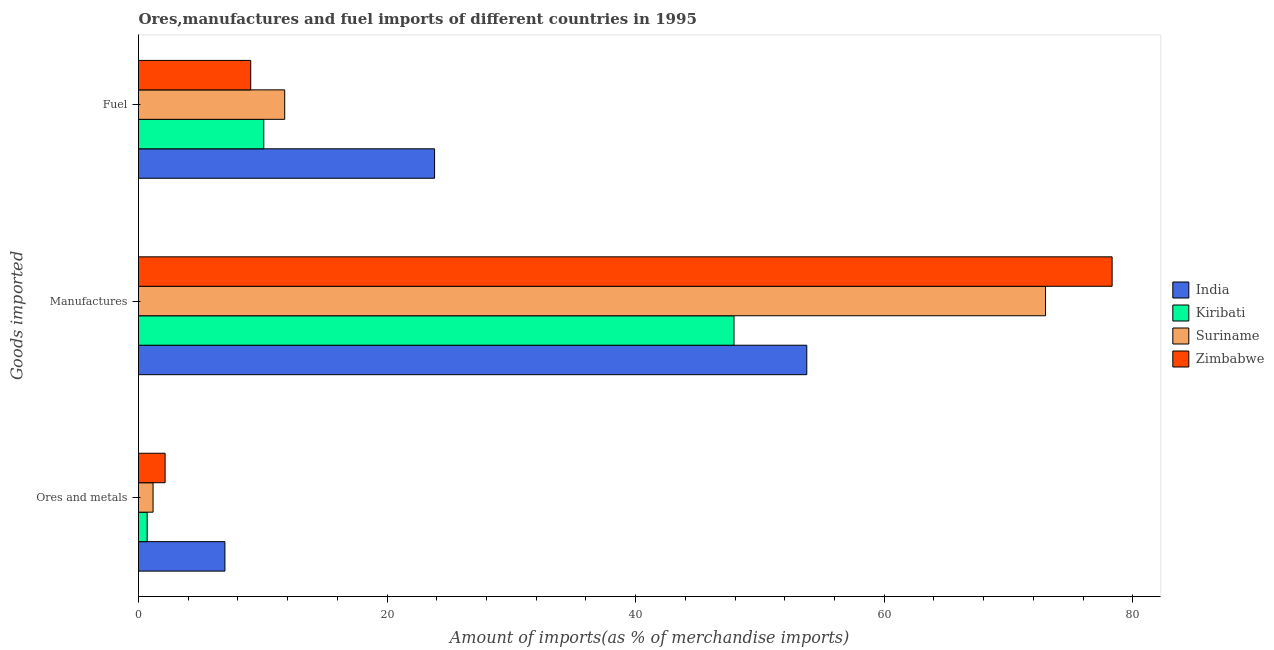How many different coloured bars are there?
Keep it short and to the point. 4. Are the number of bars on each tick of the Y-axis equal?
Offer a very short reply. Yes. How many bars are there on the 3rd tick from the top?
Your response must be concise. 4. How many bars are there on the 3rd tick from the bottom?
Your answer should be compact. 4. What is the label of the 3rd group of bars from the top?
Provide a short and direct response. Ores and metals. What is the percentage of manufactures imports in India?
Offer a terse response. 53.77. Across all countries, what is the maximum percentage of ores and metals imports?
Keep it short and to the point. 6.95. Across all countries, what is the minimum percentage of manufactures imports?
Keep it short and to the point. 47.92. In which country was the percentage of manufactures imports maximum?
Your answer should be very brief. Zimbabwe. In which country was the percentage of manufactures imports minimum?
Offer a very short reply. Kiribati. What is the total percentage of fuel imports in the graph?
Keep it short and to the point. 54.7. What is the difference between the percentage of fuel imports in Zimbabwe and that in Kiribati?
Offer a terse response. -1.05. What is the difference between the percentage of manufactures imports in Kiribati and the percentage of fuel imports in India?
Provide a succinct answer. 24.1. What is the average percentage of manufactures imports per country?
Give a very brief answer. 63.25. What is the difference between the percentage of manufactures imports and percentage of ores and metals imports in India?
Give a very brief answer. 46.82. What is the ratio of the percentage of manufactures imports in Suriname to that in Zimbabwe?
Offer a very short reply. 0.93. Is the percentage of manufactures imports in India less than that in Kiribati?
Provide a short and direct response. No. What is the difference between the highest and the second highest percentage of manufactures imports?
Provide a short and direct response. 5.36. What is the difference between the highest and the lowest percentage of fuel imports?
Your answer should be very brief. 14.79. In how many countries, is the percentage of fuel imports greater than the average percentage of fuel imports taken over all countries?
Your answer should be very brief. 1. Is the sum of the percentage of ores and metals imports in Kiribati and India greater than the maximum percentage of fuel imports across all countries?
Your answer should be very brief. No. What does the 1st bar from the top in Fuel represents?
Your answer should be very brief. Zimbabwe. What does the 2nd bar from the bottom in Fuel represents?
Offer a terse response. Kiribati. How many bars are there?
Provide a succinct answer. 12. What is the difference between two consecutive major ticks on the X-axis?
Provide a short and direct response. 20. Does the graph contain any zero values?
Ensure brevity in your answer.  No. Does the graph contain grids?
Offer a terse response. No. Where does the legend appear in the graph?
Provide a short and direct response. Center right. How are the legend labels stacked?
Make the answer very short. Vertical. What is the title of the graph?
Offer a terse response. Ores,manufactures and fuel imports of different countries in 1995. What is the label or title of the X-axis?
Offer a terse response. Amount of imports(as % of merchandise imports). What is the label or title of the Y-axis?
Ensure brevity in your answer.  Goods imported. What is the Amount of imports(as % of merchandise imports) in India in Ores and metals?
Provide a succinct answer. 6.95. What is the Amount of imports(as % of merchandise imports) of Kiribati in Ores and metals?
Offer a very short reply. 0.7. What is the Amount of imports(as % of merchandise imports) of Suriname in Ores and metals?
Your answer should be compact. 1.17. What is the Amount of imports(as % of merchandise imports) of Zimbabwe in Ores and metals?
Your response must be concise. 2.14. What is the Amount of imports(as % of merchandise imports) in India in Manufactures?
Provide a short and direct response. 53.77. What is the Amount of imports(as % of merchandise imports) of Kiribati in Manufactures?
Provide a succinct answer. 47.92. What is the Amount of imports(as % of merchandise imports) of Suriname in Manufactures?
Your response must be concise. 72.98. What is the Amount of imports(as % of merchandise imports) in Zimbabwe in Manufactures?
Offer a terse response. 78.34. What is the Amount of imports(as % of merchandise imports) in India in Fuel?
Offer a terse response. 23.82. What is the Amount of imports(as % of merchandise imports) in Kiribati in Fuel?
Your response must be concise. 10.08. What is the Amount of imports(as % of merchandise imports) of Suriname in Fuel?
Your answer should be very brief. 11.76. What is the Amount of imports(as % of merchandise imports) in Zimbabwe in Fuel?
Ensure brevity in your answer.  9.03. Across all Goods imported, what is the maximum Amount of imports(as % of merchandise imports) of India?
Provide a short and direct response. 53.77. Across all Goods imported, what is the maximum Amount of imports(as % of merchandise imports) of Kiribati?
Offer a very short reply. 47.92. Across all Goods imported, what is the maximum Amount of imports(as % of merchandise imports) of Suriname?
Provide a short and direct response. 72.98. Across all Goods imported, what is the maximum Amount of imports(as % of merchandise imports) in Zimbabwe?
Keep it short and to the point. 78.34. Across all Goods imported, what is the minimum Amount of imports(as % of merchandise imports) of India?
Make the answer very short. 6.95. Across all Goods imported, what is the minimum Amount of imports(as % of merchandise imports) of Kiribati?
Provide a succinct answer. 0.7. Across all Goods imported, what is the minimum Amount of imports(as % of merchandise imports) of Suriname?
Give a very brief answer. 1.17. Across all Goods imported, what is the minimum Amount of imports(as % of merchandise imports) in Zimbabwe?
Offer a very short reply. 2.14. What is the total Amount of imports(as % of merchandise imports) of India in the graph?
Make the answer very short. 84.55. What is the total Amount of imports(as % of merchandise imports) of Kiribati in the graph?
Provide a short and direct response. 58.7. What is the total Amount of imports(as % of merchandise imports) in Suriname in the graph?
Your answer should be compact. 85.92. What is the total Amount of imports(as % of merchandise imports) of Zimbabwe in the graph?
Offer a terse response. 89.51. What is the difference between the Amount of imports(as % of merchandise imports) in India in Ores and metals and that in Manufactures?
Ensure brevity in your answer.  -46.82. What is the difference between the Amount of imports(as % of merchandise imports) in Kiribati in Ores and metals and that in Manufactures?
Give a very brief answer. -47.22. What is the difference between the Amount of imports(as % of merchandise imports) of Suriname in Ores and metals and that in Manufactures?
Offer a terse response. -71.81. What is the difference between the Amount of imports(as % of merchandise imports) of Zimbabwe in Ores and metals and that in Manufactures?
Ensure brevity in your answer.  -76.2. What is the difference between the Amount of imports(as % of merchandise imports) of India in Ores and metals and that in Fuel?
Make the answer very short. -16.87. What is the difference between the Amount of imports(as % of merchandise imports) of Kiribati in Ores and metals and that in Fuel?
Your answer should be very brief. -9.38. What is the difference between the Amount of imports(as % of merchandise imports) in Suriname in Ores and metals and that in Fuel?
Keep it short and to the point. -10.59. What is the difference between the Amount of imports(as % of merchandise imports) of Zimbabwe in Ores and metals and that in Fuel?
Ensure brevity in your answer.  -6.89. What is the difference between the Amount of imports(as % of merchandise imports) of India in Manufactures and that in Fuel?
Your answer should be very brief. 29.95. What is the difference between the Amount of imports(as % of merchandise imports) of Kiribati in Manufactures and that in Fuel?
Offer a very short reply. 37.84. What is the difference between the Amount of imports(as % of merchandise imports) in Suriname in Manufactures and that in Fuel?
Your response must be concise. 61.22. What is the difference between the Amount of imports(as % of merchandise imports) in Zimbabwe in Manufactures and that in Fuel?
Your response must be concise. 69.31. What is the difference between the Amount of imports(as % of merchandise imports) in India in Ores and metals and the Amount of imports(as % of merchandise imports) in Kiribati in Manufactures?
Your response must be concise. -40.97. What is the difference between the Amount of imports(as % of merchandise imports) in India in Ores and metals and the Amount of imports(as % of merchandise imports) in Suriname in Manufactures?
Your response must be concise. -66.03. What is the difference between the Amount of imports(as % of merchandise imports) in India in Ores and metals and the Amount of imports(as % of merchandise imports) in Zimbabwe in Manufactures?
Give a very brief answer. -71.39. What is the difference between the Amount of imports(as % of merchandise imports) of Kiribati in Ores and metals and the Amount of imports(as % of merchandise imports) of Suriname in Manufactures?
Give a very brief answer. -72.29. What is the difference between the Amount of imports(as % of merchandise imports) in Kiribati in Ores and metals and the Amount of imports(as % of merchandise imports) in Zimbabwe in Manufactures?
Your answer should be very brief. -77.64. What is the difference between the Amount of imports(as % of merchandise imports) in Suriname in Ores and metals and the Amount of imports(as % of merchandise imports) in Zimbabwe in Manufactures?
Your response must be concise. -77.17. What is the difference between the Amount of imports(as % of merchandise imports) in India in Ores and metals and the Amount of imports(as % of merchandise imports) in Kiribati in Fuel?
Make the answer very short. -3.13. What is the difference between the Amount of imports(as % of merchandise imports) in India in Ores and metals and the Amount of imports(as % of merchandise imports) in Suriname in Fuel?
Provide a succinct answer. -4.81. What is the difference between the Amount of imports(as % of merchandise imports) of India in Ores and metals and the Amount of imports(as % of merchandise imports) of Zimbabwe in Fuel?
Your answer should be compact. -2.08. What is the difference between the Amount of imports(as % of merchandise imports) of Kiribati in Ores and metals and the Amount of imports(as % of merchandise imports) of Suriname in Fuel?
Your answer should be very brief. -11.07. What is the difference between the Amount of imports(as % of merchandise imports) of Kiribati in Ores and metals and the Amount of imports(as % of merchandise imports) of Zimbabwe in Fuel?
Your answer should be very brief. -8.33. What is the difference between the Amount of imports(as % of merchandise imports) of Suriname in Ores and metals and the Amount of imports(as % of merchandise imports) of Zimbabwe in Fuel?
Your answer should be compact. -7.86. What is the difference between the Amount of imports(as % of merchandise imports) in India in Manufactures and the Amount of imports(as % of merchandise imports) in Kiribati in Fuel?
Your answer should be compact. 43.69. What is the difference between the Amount of imports(as % of merchandise imports) in India in Manufactures and the Amount of imports(as % of merchandise imports) in Suriname in Fuel?
Your response must be concise. 42.01. What is the difference between the Amount of imports(as % of merchandise imports) in India in Manufactures and the Amount of imports(as % of merchandise imports) in Zimbabwe in Fuel?
Your answer should be very brief. 44.74. What is the difference between the Amount of imports(as % of merchandise imports) of Kiribati in Manufactures and the Amount of imports(as % of merchandise imports) of Suriname in Fuel?
Your answer should be very brief. 36.15. What is the difference between the Amount of imports(as % of merchandise imports) of Kiribati in Manufactures and the Amount of imports(as % of merchandise imports) of Zimbabwe in Fuel?
Your answer should be compact. 38.89. What is the difference between the Amount of imports(as % of merchandise imports) in Suriname in Manufactures and the Amount of imports(as % of merchandise imports) in Zimbabwe in Fuel?
Make the answer very short. 63.95. What is the average Amount of imports(as % of merchandise imports) in India per Goods imported?
Ensure brevity in your answer.  28.18. What is the average Amount of imports(as % of merchandise imports) in Kiribati per Goods imported?
Offer a very short reply. 19.57. What is the average Amount of imports(as % of merchandise imports) of Suriname per Goods imported?
Your answer should be compact. 28.64. What is the average Amount of imports(as % of merchandise imports) of Zimbabwe per Goods imported?
Your answer should be compact. 29.84. What is the difference between the Amount of imports(as % of merchandise imports) of India and Amount of imports(as % of merchandise imports) of Kiribati in Ores and metals?
Provide a short and direct response. 6.26. What is the difference between the Amount of imports(as % of merchandise imports) in India and Amount of imports(as % of merchandise imports) in Suriname in Ores and metals?
Your response must be concise. 5.78. What is the difference between the Amount of imports(as % of merchandise imports) of India and Amount of imports(as % of merchandise imports) of Zimbabwe in Ores and metals?
Provide a short and direct response. 4.81. What is the difference between the Amount of imports(as % of merchandise imports) in Kiribati and Amount of imports(as % of merchandise imports) in Suriname in Ores and metals?
Your answer should be compact. -0.47. What is the difference between the Amount of imports(as % of merchandise imports) of Kiribati and Amount of imports(as % of merchandise imports) of Zimbabwe in Ores and metals?
Offer a terse response. -1.44. What is the difference between the Amount of imports(as % of merchandise imports) in Suriname and Amount of imports(as % of merchandise imports) in Zimbabwe in Ores and metals?
Keep it short and to the point. -0.97. What is the difference between the Amount of imports(as % of merchandise imports) of India and Amount of imports(as % of merchandise imports) of Kiribati in Manufactures?
Your answer should be very brief. 5.85. What is the difference between the Amount of imports(as % of merchandise imports) of India and Amount of imports(as % of merchandise imports) of Suriname in Manufactures?
Your answer should be compact. -19.21. What is the difference between the Amount of imports(as % of merchandise imports) of India and Amount of imports(as % of merchandise imports) of Zimbabwe in Manufactures?
Your answer should be compact. -24.57. What is the difference between the Amount of imports(as % of merchandise imports) in Kiribati and Amount of imports(as % of merchandise imports) in Suriname in Manufactures?
Offer a terse response. -25.07. What is the difference between the Amount of imports(as % of merchandise imports) of Kiribati and Amount of imports(as % of merchandise imports) of Zimbabwe in Manufactures?
Your answer should be compact. -30.42. What is the difference between the Amount of imports(as % of merchandise imports) of Suriname and Amount of imports(as % of merchandise imports) of Zimbabwe in Manufactures?
Ensure brevity in your answer.  -5.36. What is the difference between the Amount of imports(as % of merchandise imports) of India and Amount of imports(as % of merchandise imports) of Kiribati in Fuel?
Offer a very short reply. 13.74. What is the difference between the Amount of imports(as % of merchandise imports) of India and Amount of imports(as % of merchandise imports) of Suriname in Fuel?
Your response must be concise. 12.06. What is the difference between the Amount of imports(as % of merchandise imports) in India and Amount of imports(as % of merchandise imports) in Zimbabwe in Fuel?
Offer a very short reply. 14.79. What is the difference between the Amount of imports(as % of merchandise imports) in Kiribati and Amount of imports(as % of merchandise imports) in Suriname in Fuel?
Offer a very short reply. -1.68. What is the difference between the Amount of imports(as % of merchandise imports) of Kiribati and Amount of imports(as % of merchandise imports) of Zimbabwe in Fuel?
Provide a succinct answer. 1.05. What is the difference between the Amount of imports(as % of merchandise imports) of Suriname and Amount of imports(as % of merchandise imports) of Zimbabwe in Fuel?
Give a very brief answer. 2.73. What is the ratio of the Amount of imports(as % of merchandise imports) of India in Ores and metals to that in Manufactures?
Give a very brief answer. 0.13. What is the ratio of the Amount of imports(as % of merchandise imports) in Kiribati in Ores and metals to that in Manufactures?
Give a very brief answer. 0.01. What is the ratio of the Amount of imports(as % of merchandise imports) in Suriname in Ores and metals to that in Manufactures?
Make the answer very short. 0.02. What is the ratio of the Amount of imports(as % of merchandise imports) in Zimbabwe in Ores and metals to that in Manufactures?
Keep it short and to the point. 0.03. What is the ratio of the Amount of imports(as % of merchandise imports) in India in Ores and metals to that in Fuel?
Ensure brevity in your answer.  0.29. What is the ratio of the Amount of imports(as % of merchandise imports) in Kiribati in Ores and metals to that in Fuel?
Keep it short and to the point. 0.07. What is the ratio of the Amount of imports(as % of merchandise imports) in Suriname in Ores and metals to that in Fuel?
Keep it short and to the point. 0.1. What is the ratio of the Amount of imports(as % of merchandise imports) of Zimbabwe in Ores and metals to that in Fuel?
Your response must be concise. 0.24. What is the ratio of the Amount of imports(as % of merchandise imports) in India in Manufactures to that in Fuel?
Offer a very short reply. 2.26. What is the ratio of the Amount of imports(as % of merchandise imports) of Kiribati in Manufactures to that in Fuel?
Provide a short and direct response. 4.75. What is the ratio of the Amount of imports(as % of merchandise imports) of Suriname in Manufactures to that in Fuel?
Give a very brief answer. 6.2. What is the ratio of the Amount of imports(as % of merchandise imports) of Zimbabwe in Manufactures to that in Fuel?
Give a very brief answer. 8.68. What is the difference between the highest and the second highest Amount of imports(as % of merchandise imports) of India?
Your response must be concise. 29.95. What is the difference between the highest and the second highest Amount of imports(as % of merchandise imports) of Kiribati?
Make the answer very short. 37.84. What is the difference between the highest and the second highest Amount of imports(as % of merchandise imports) in Suriname?
Your answer should be very brief. 61.22. What is the difference between the highest and the second highest Amount of imports(as % of merchandise imports) in Zimbabwe?
Give a very brief answer. 69.31. What is the difference between the highest and the lowest Amount of imports(as % of merchandise imports) of India?
Your answer should be very brief. 46.82. What is the difference between the highest and the lowest Amount of imports(as % of merchandise imports) of Kiribati?
Offer a very short reply. 47.22. What is the difference between the highest and the lowest Amount of imports(as % of merchandise imports) in Suriname?
Your answer should be compact. 71.81. What is the difference between the highest and the lowest Amount of imports(as % of merchandise imports) in Zimbabwe?
Ensure brevity in your answer.  76.2. 